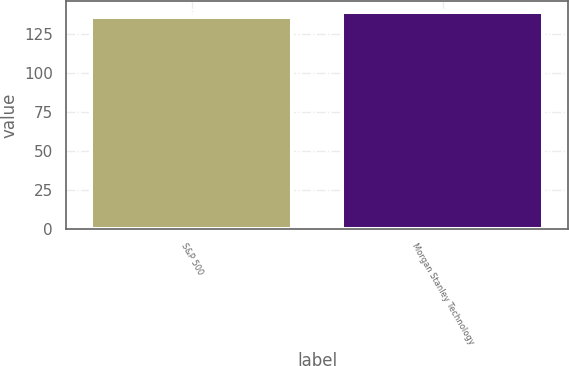Convert chart to OTSL. <chart><loc_0><loc_0><loc_500><loc_500><bar_chart><fcel>S&P 500<fcel>Morgan Stanley Technology<nl><fcel>136.21<fcel>139.39<nl></chart> 